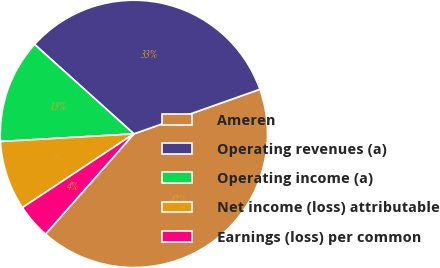Convert chart to OTSL. <chart><loc_0><loc_0><loc_500><loc_500><pie_chart><fcel>Ameren<fcel>Operating revenues (a)<fcel>Operating income (a)<fcel>Net income (loss) attributable<fcel>Earnings (loss) per common<nl><fcel>41.91%<fcel>32.92%<fcel>12.58%<fcel>8.39%<fcel>4.2%<nl></chart> 